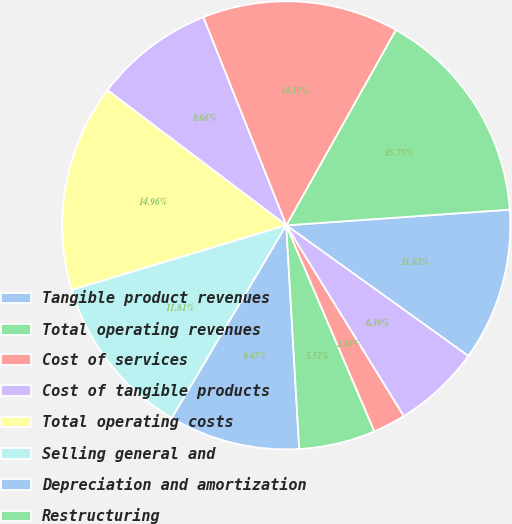Convert chart. <chart><loc_0><loc_0><loc_500><loc_500><pie_chart><fcel>Tangible product revenues<fcel>Total operating revenues<fcel>Cost of services<fcel>Cost of tangible products<fcel>Total operating costs<fcel>Selling general and<fcel>Depreciation and amortization<fcel>Restructuring<fcel>Goodwill impairments<fcel>(Income) expense from<nl><fcel>11.02%<fcel>15.75%<fcel>14.17%<fcel>8.66%<fcel>14.96%<fcel>11.81%<fcel>9.45%<fcel>5.51%<fcel>2.36%<fcel>6.3%<nl></chart> 